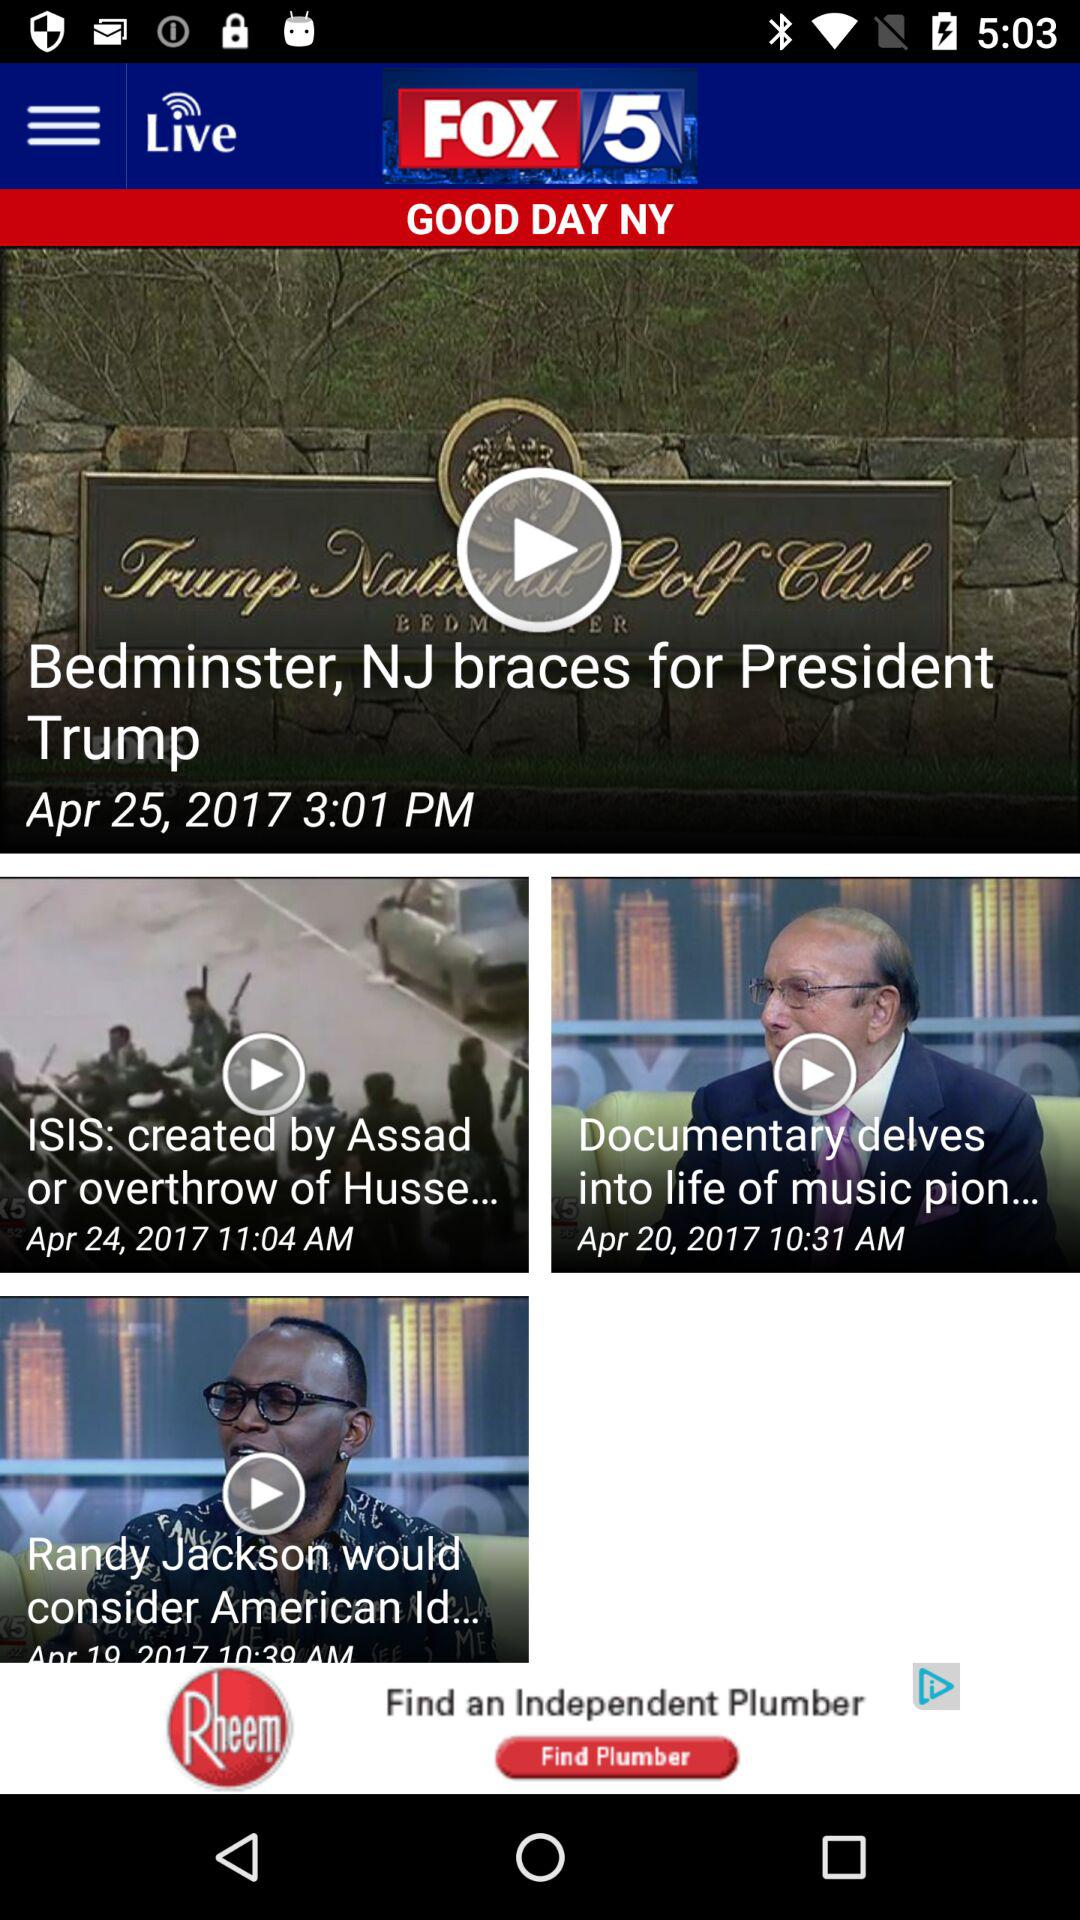What is the published date of the news "Bedminster, NJ braces for President Trump"? The published date of the news is April 25, 2017. 